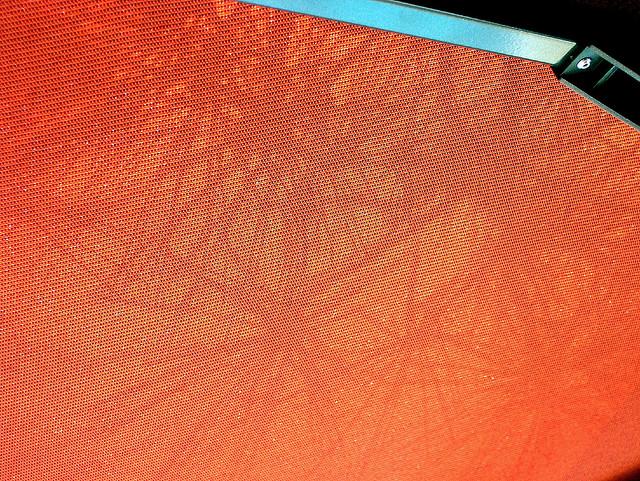Are those trees seen through the net?
Keep it brief. Yes. Is the screw a Phillips or flathead?
Give a very brief answer. Phillips. What color is the net?
Concise answer only. Orange. 